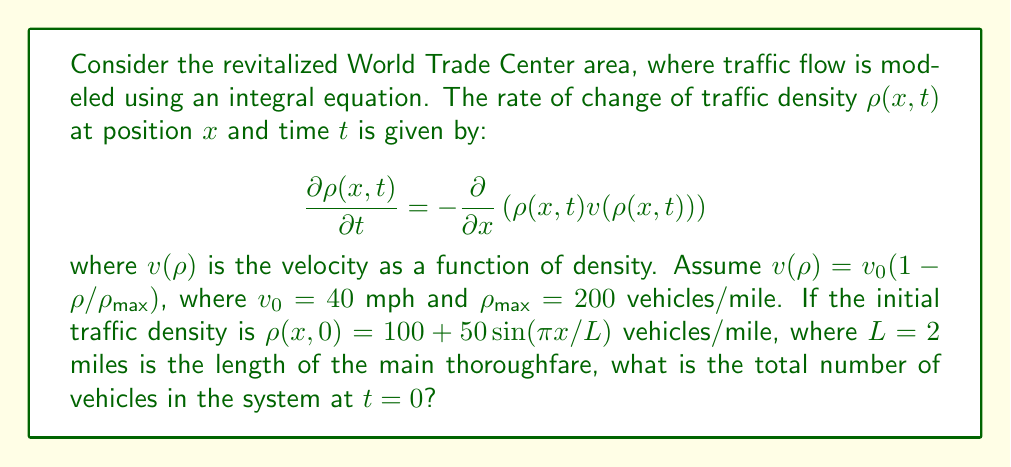Teach me how to tackle this problem. To solve this problem, we need to integrate the initial traffic density function over the length of the thoroughfare. Let's approach this step-by-step:

1) The initial traffic density is given by:
   $$\rho(x,0) = 100 + 50\sin(\pi x/L)$$
   where $L = 2$ miles.

2) To find the total number of vehicles, we need to integrate this function over the length of the road:
   $$N = \int_0^L \rho(x,0) dx$$

3) Substituting the given function:
   $$N = \int_0^2 \left(100 + 50\sin(\pi x/2)\right) dx$$

4) We can split this into two integrals:
   $$N = \int_0^2 100 dx + \int_0^2 50\sin(\pi x/2) dx$$

5) The first integral is straightforward:
   $$\int_0^2 100 dx = 100x \Big|_0^2 = 200$$

6) For the second integral, we can use the substitution $u = \pi x/2$:
   $$\int_0^2 50\sin(\pi x/2) dx = \frac{100}{\pi/2} \int_0^\pi \sin(u) du$$

7) Evaluating this integral:
   $$\frac{100}{\pi/2} \left[-\cos(u)\right]_0^\pi = \frac{200}{\pi} \cdot 2 = \frac{400}{\pi}$$

8) Adding the results from steps 5 and 7:
   $$N = 200 + \frac{400}{\pi}$$

This gives us the total number of vehicles in the system at $t=0$.
Answer: $200 + \frac{400}{\pi}$ vehicles 